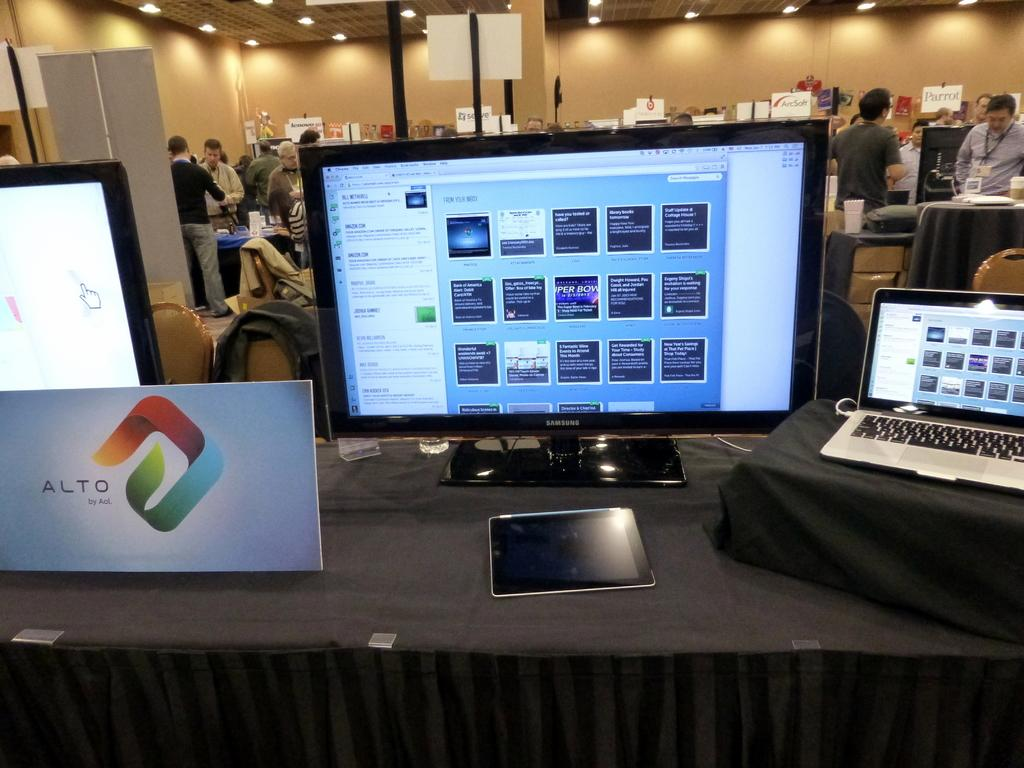<image>
Provide a brief description of the given image. A monitor and laptop with a sign for Alto next to them 